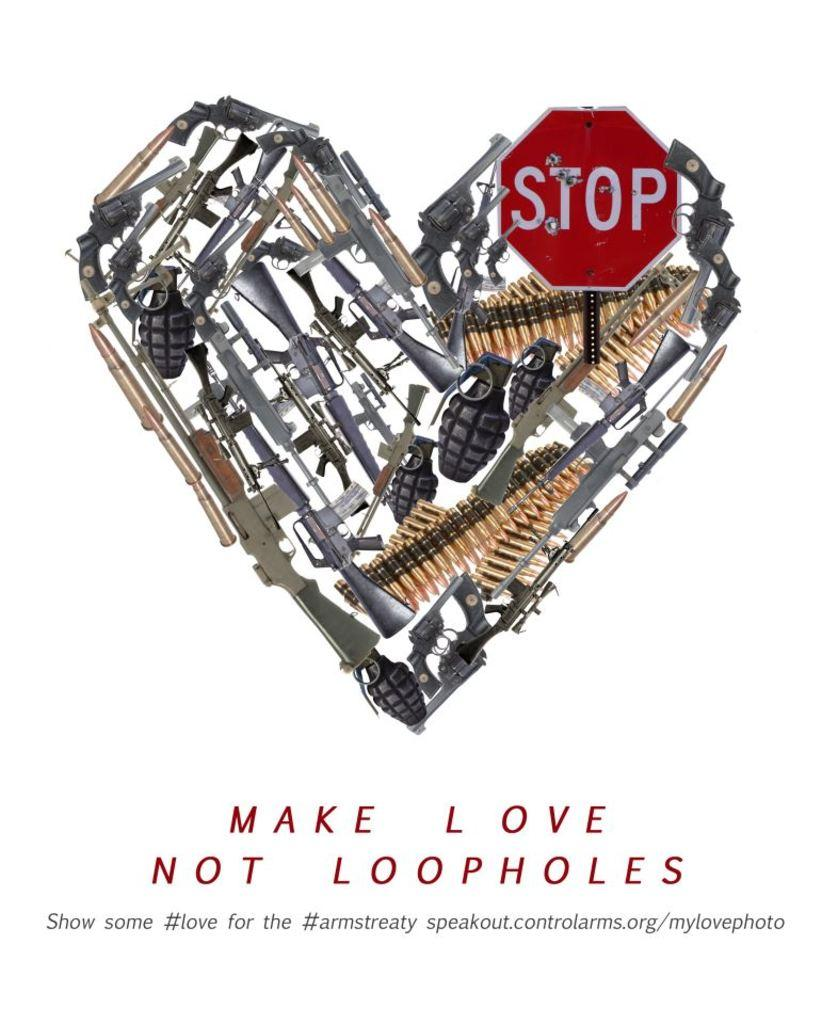<image>
Write a terse but informative summary of the picture. a stop sign that has make love not loopholes on it 